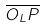<formula> <loc_0><loc_0><loc_500><loc_500>\overline { O _ { L } P }</formula> 